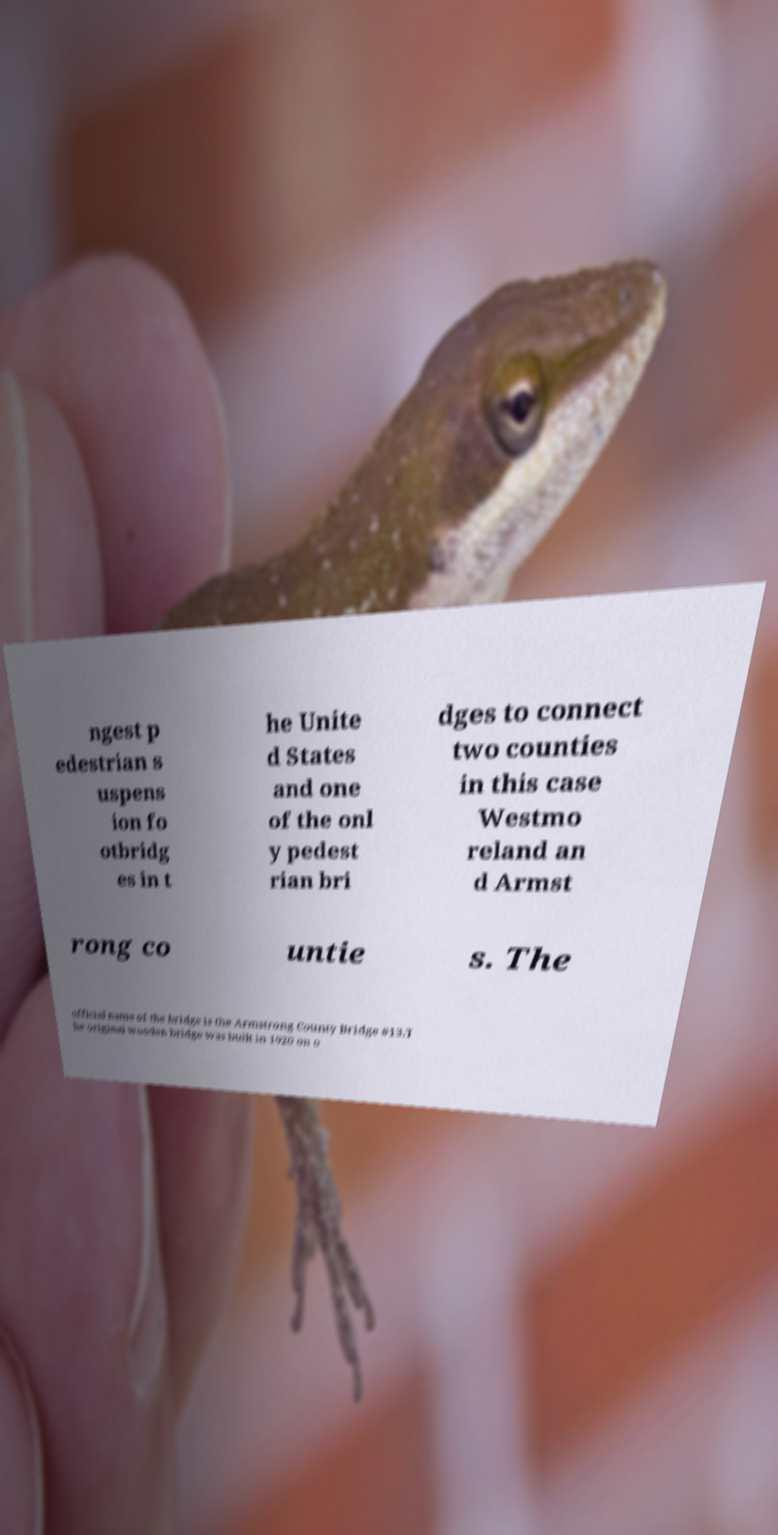Please identify and transcribe the text found in this image. ngest p edestrian s uspens ion fo otbridg es in t he Unite d States and one of the onl y pedest rian bri dges to connect two counties in this case Westmo reland an d Armst rong co untie s. The official name of the bridge is the Armstrong County Bridge #13.T he original wooden bridge was built in 1920 on o 